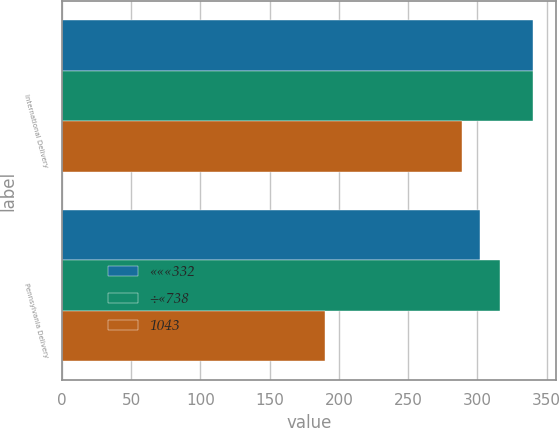Convert chart to OTSL. <chart><loc_0><loc_0><loc_500><loc_500><stacked_bar_chart><ecel><fcel>International Delivery<fcel>Pennsylvania Delivery<nl><fcel>«««332<fcel>340<fcel>302<nl><fcel>÷«738<fcel>340<fcel>316<nl><fcel>1043<fcel>289<fcel>190<nl></chart> 